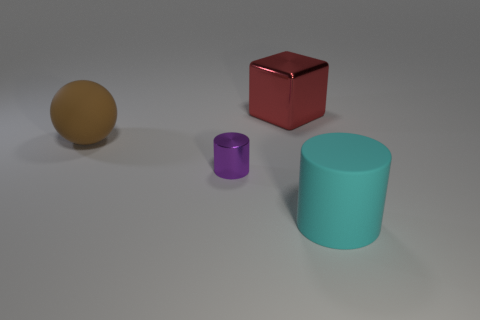Add 4 small cyan rubber spheres. How many objects exist? 8 Subtract all yellow blocks. Subtract all yellow balls. How many blocks are left? 1 Subtract all yellow cubes. How many yellow cylinders are left? 0 Subtract all cyan cylinders. How many cylinders are left? 1 Subtract all brown metal objects. Subtract all large rubber balls. How many objects are left? 3 Add 2 big brown matte spheres. How many big brown matte spheres are left? 3 Add 2 small gray matte blocks. How many small gray matte blocks exist? 2 Subtract 0 green cubes. How many objects are left? 4 Subtract all cubes. How many objects are left? 3 Subtract 1 blocks. How many blocks are left? 0 